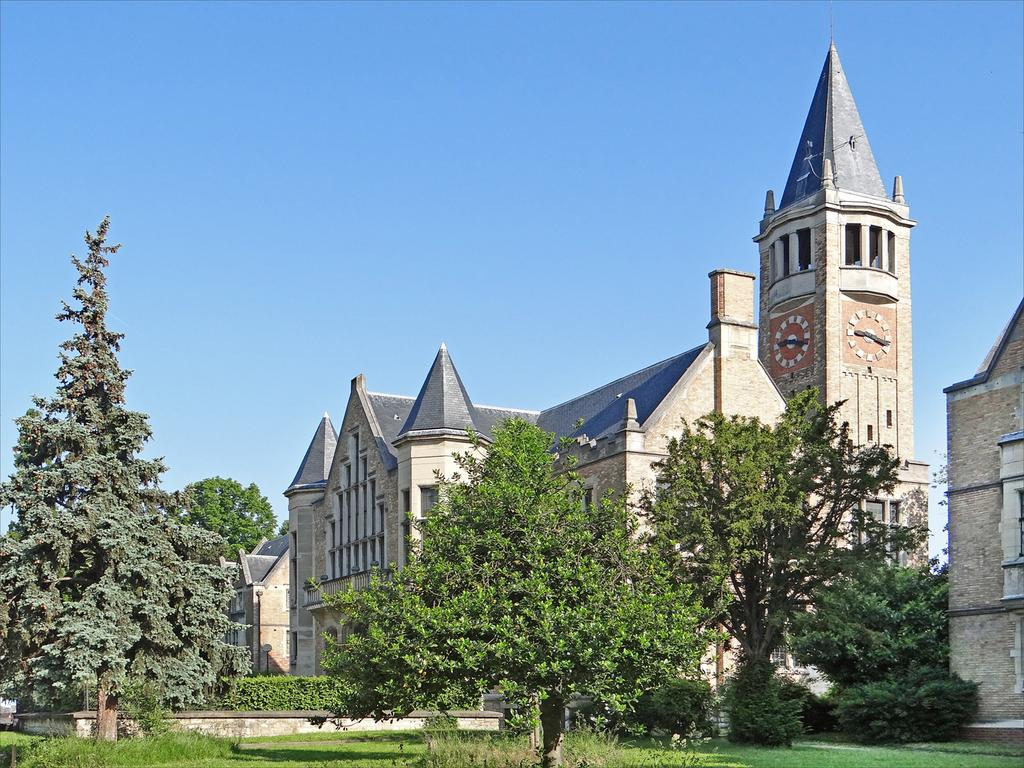What type of structures can be seen in the image? There are buildings in the image. Is there any specific architectural feature in the image? Yes, there is a clock tower in the image. What type of vegetation is present in the foreground of the image? There are trees in the foreground of the image. What type of ground cover is visible at the bottom of the image? There is grass at the bottom of the image. What part of the natural environment is visible in the image? The sky is visible at the top of the image. Can you see any squirrels stretching in the image? There are no squirrels or stretching activities visible in the image. What type of rays can be seen emanating from the clock tower in the image? There are no rays visible in the image; the clock tower is a stationary structure. 